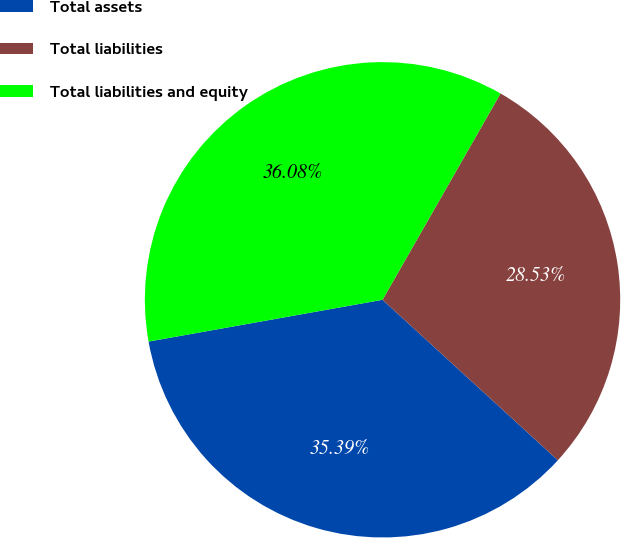<chart> <loc_0><loc_0><loc_500><loc_500><pie_chart><fcel>Total assets<fcel>Total liabilities<fcel>Total liabilities and equity<nl><fcel>35.39%<fcel>28.53%<fcel>36.08%<nl></chart> 